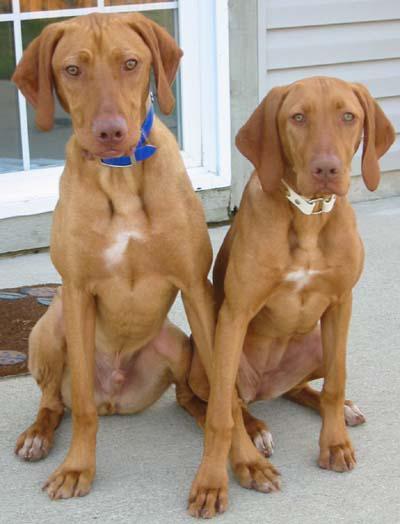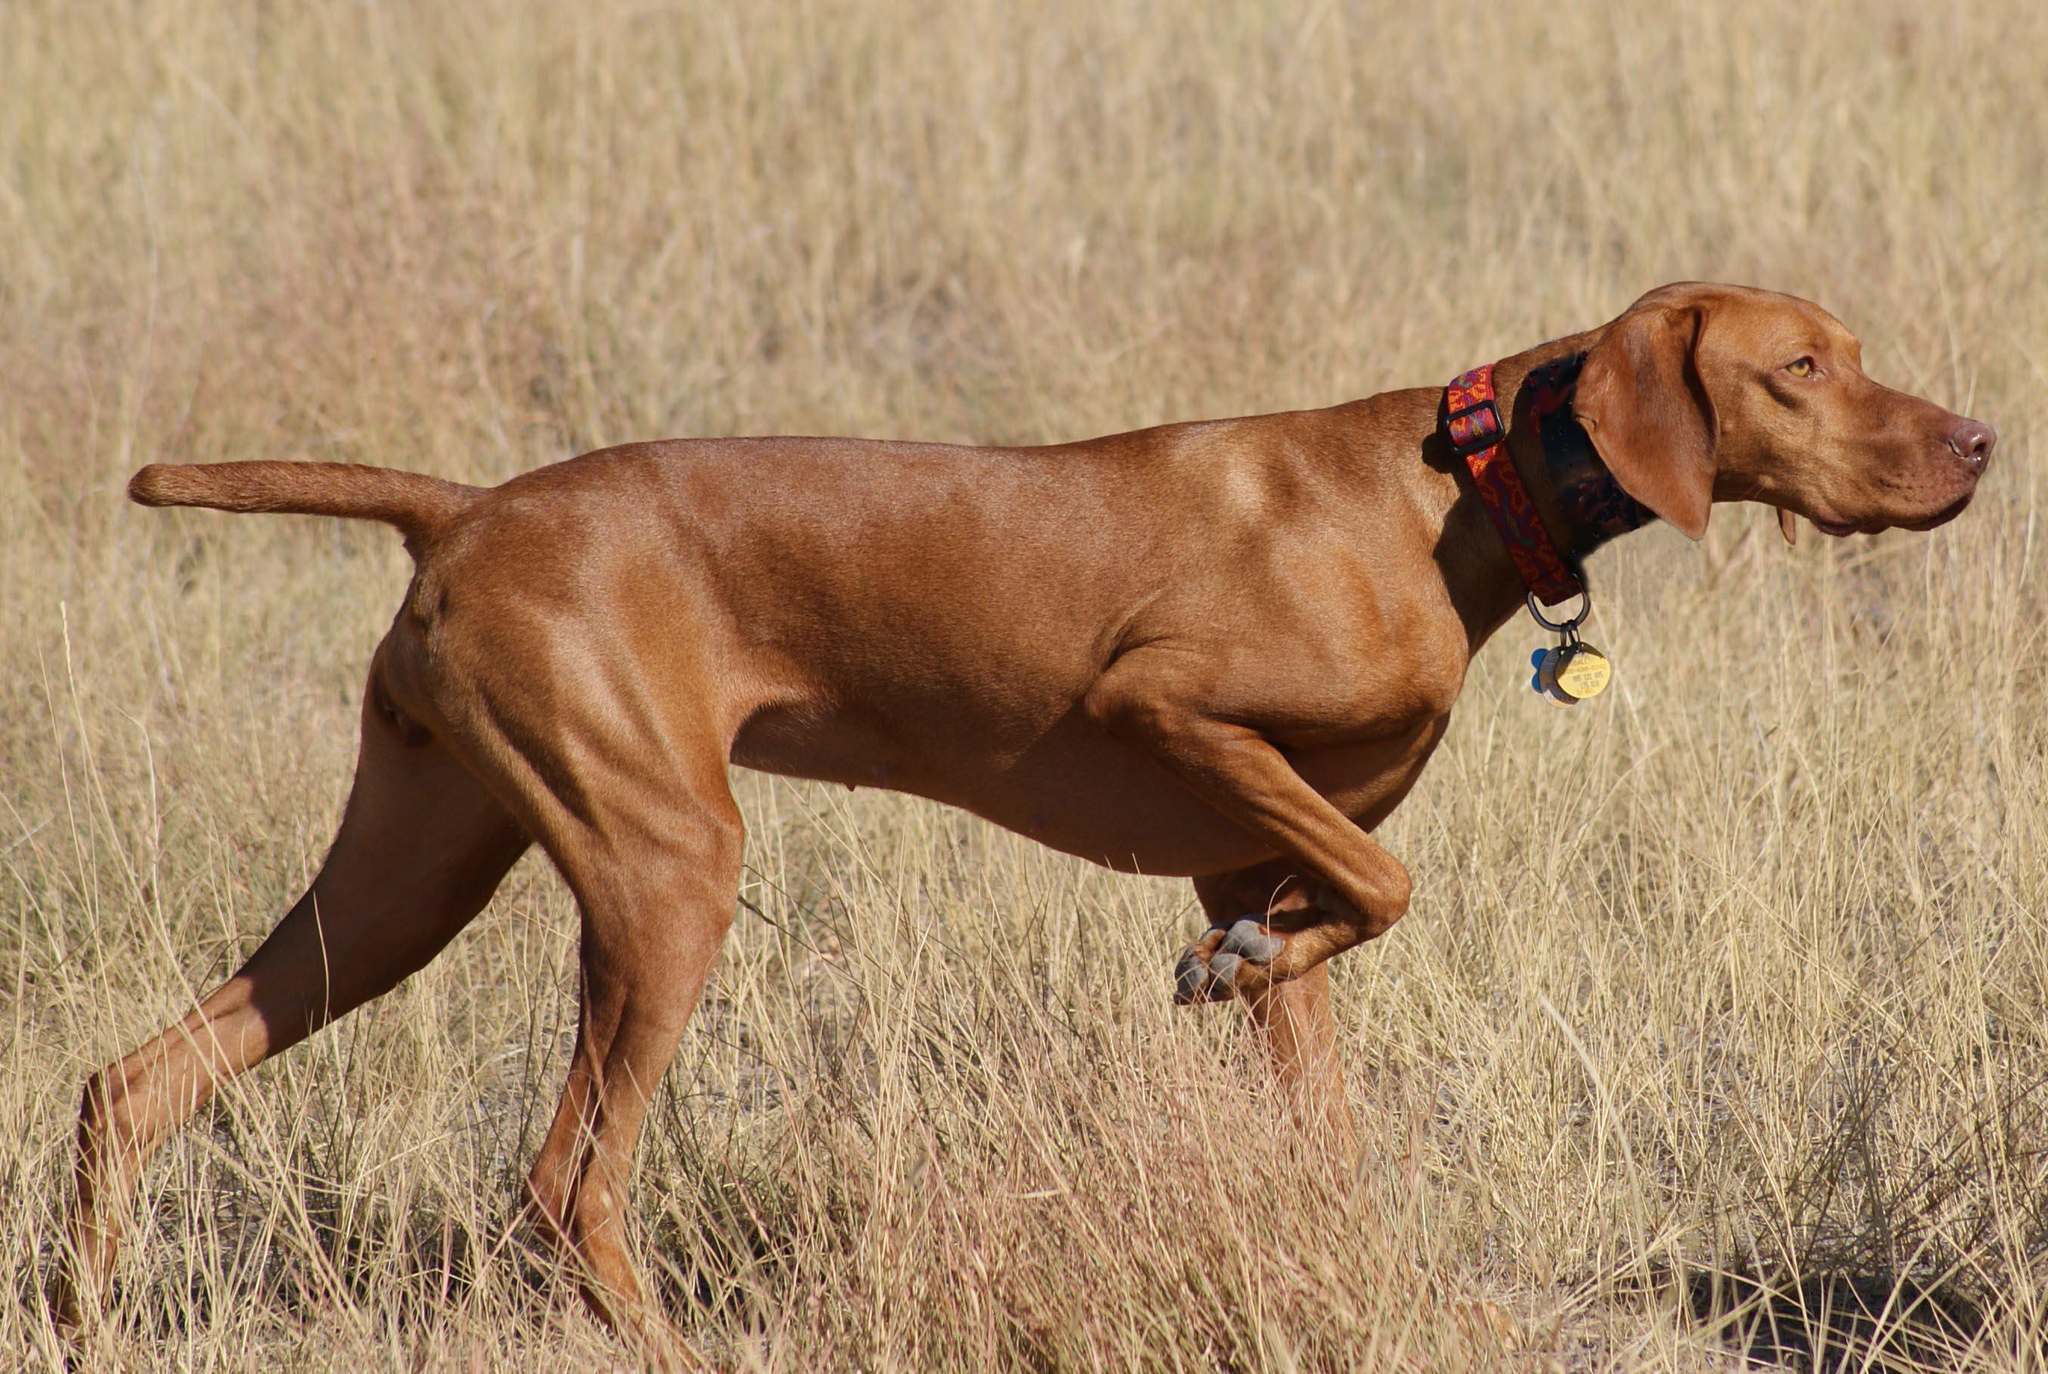The first image is the image on the left, the second image is the image on the right. Examine the images to the left and right. Is the description "Each image contains just one dog, and the left image features a young dog reclining with its head upright and front paws forward." accurate? Answer yes or no. No. The first image is the image on the left, the second image is the image on the right. Assess this claim about the two images: "There are three dogs.". Correct or not? Answer yes or no. Yes. 